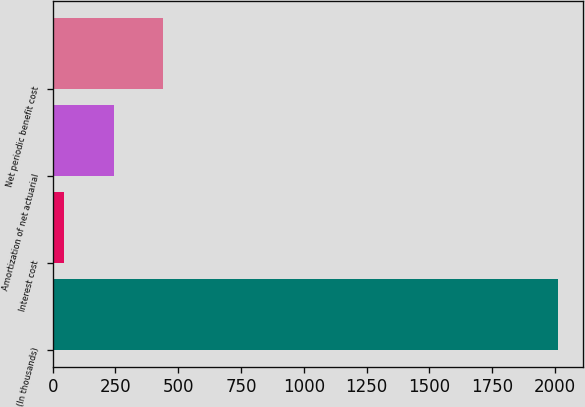<chart> <loc_0><loc_0><loc_500><loc_500><bar_chart><fcel>(In thousands)<fcel>Interest cost<fcel>Amortization of net actuarial<fcel>Net periodic benefit cost<nl><fcel>2012<fcel>47<fcel>243.5<fcel>440<nl></chart> 